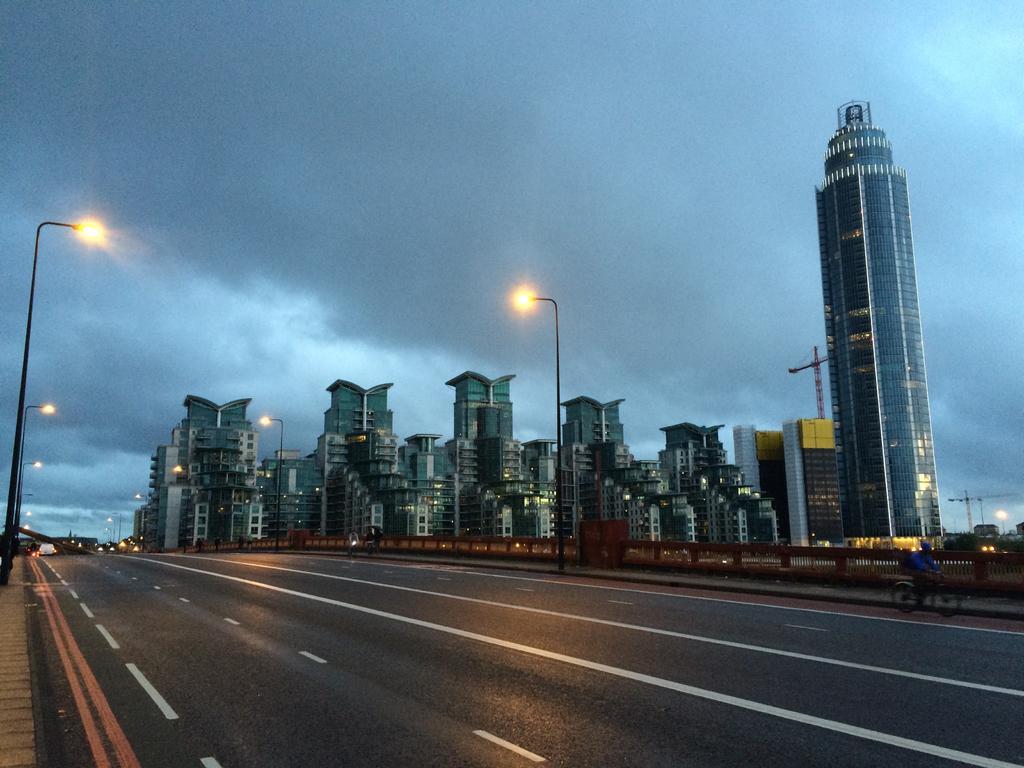Could you give a brief overview of what you see in this image? In the foreground of this image, there is a road. On the left, there are light poles. In the background, there are buildings, few light poles and the sky. We can also see a man riding bicycle on the road. 